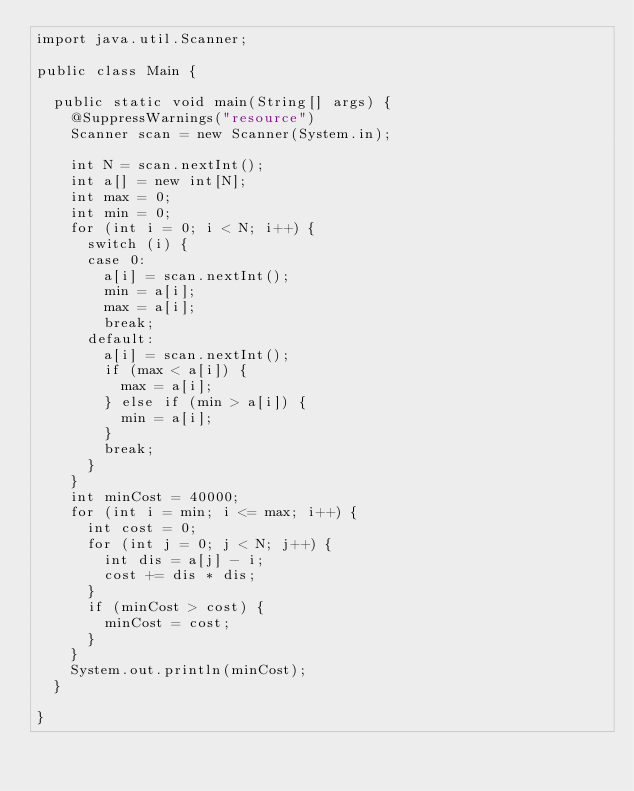Convert code to text. <code><loc_0><loc_0><loc_500><loc_500><_Java_>import java.util.Scanner;

public class Main {

	public static void main(String[] args) {
		@SuppressWarnings("resource")
		Scanner scan = new Scanner(System.in);

		int N = scan.nextInt();
		int a[] = new int[N];
		int max = 0;
		int min = 0;
		for (int i = 0; i < N; i++) {
			switch (i) {
			case 0:
				a[i] = scan.nextInt();
				min = a[i];
				max = a[i];
				break;
			default:
				a[i] = scan.nextInt();
				if (max < a[i]) {
					max = a[i];
				} else if (min > a[i]) {
					min = a[i];
				}
				break;
			}
		}
		int minCost = 40000;
		for (int i = min; i <= max; i++) {
			int cost = 0;
			for (int j = 0; j < N; j++) {
				int dis = a[j] - i;
				cost += dis * dis;
			}
			if (minCost > cost) {
				minCost = cost;
			}
		}
		System.out.println(minCost);
	}

}
</code> 